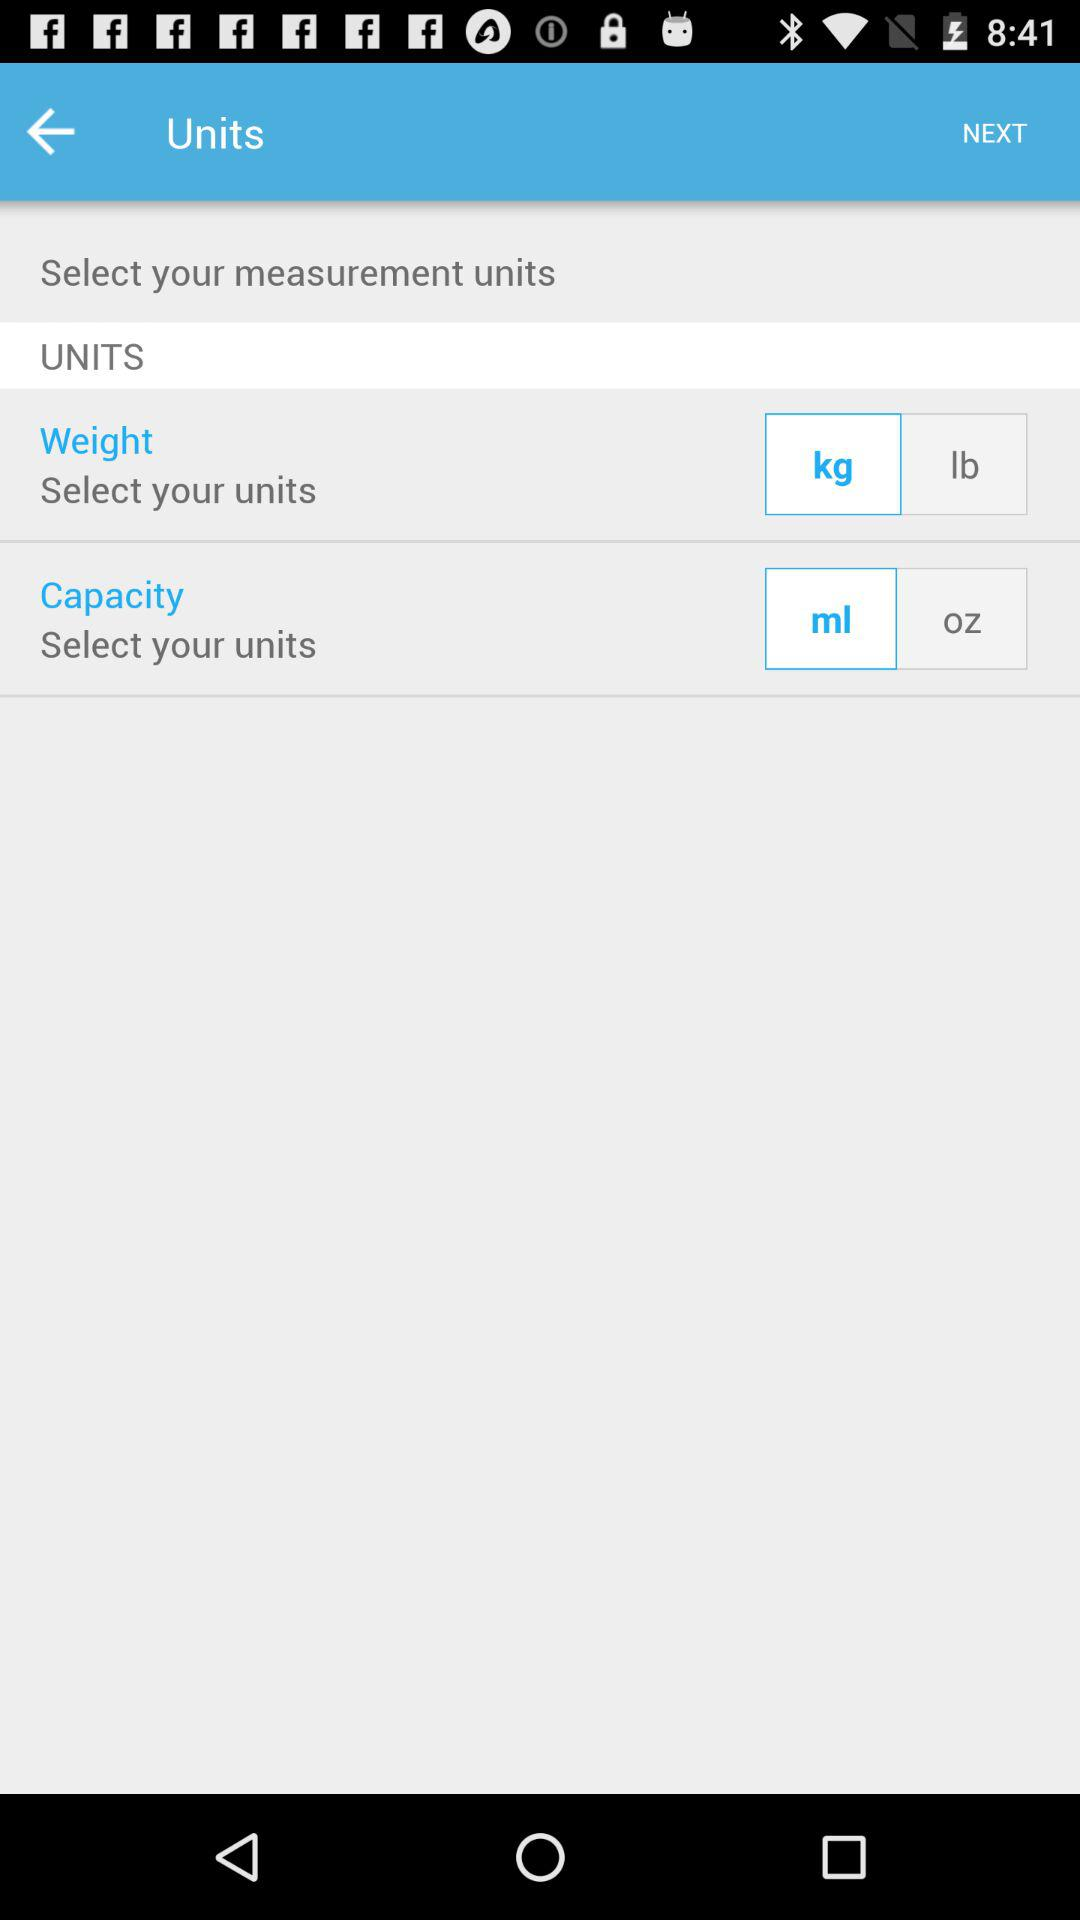How much does the user weigh in kg?
When the provided information is insufficient, respond with <no answer>. <no answer> 